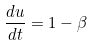<formula> <loc_0><loc_0><loc_500><loc_500>\frac { d u } { d t } = 1 - \beta</formula> 